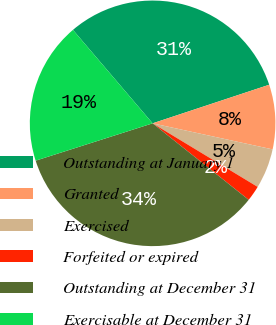Convert chart. <chart><loc_0><loc_0><loc_500><loc_500><pie_chart><fcel>Outstanding at January 1<fcel>Granted<fcel>Exercised<fcel>Forfeited or expired<fcel>Outstanding at December 31<fcel>Exercisable at December 31<nl><fcel>31.15%<fcel>8.49%<fcel>5.26%<fcel>2.04%<fcel>34.38%<fcel>18.68%<nl></chart> 